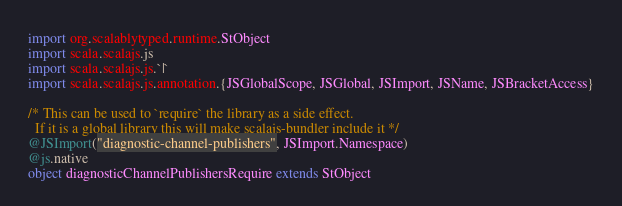Convert code to text. <code><loc_0><loc_0><loc_500><loc_500><_Scala_>
import org.scalablytyped.runtime.StObject
import scala.scalajs.js
import scala.scalajs.js.`|`
import scala.scalajs.js.annotation.{JSGlobalScope, JSGlobal, JSImport, JSName, JSBracketAccess}

/* This can be used to `require` the library as a side effect.
  If it is a global library this will make scalajs-bundler include it */
@JSImport("diagnostic-channel-publishers", JSImport.Namespace)
@js.native
object diagnosticChannelPublishersRequire extends StObject
</code> 